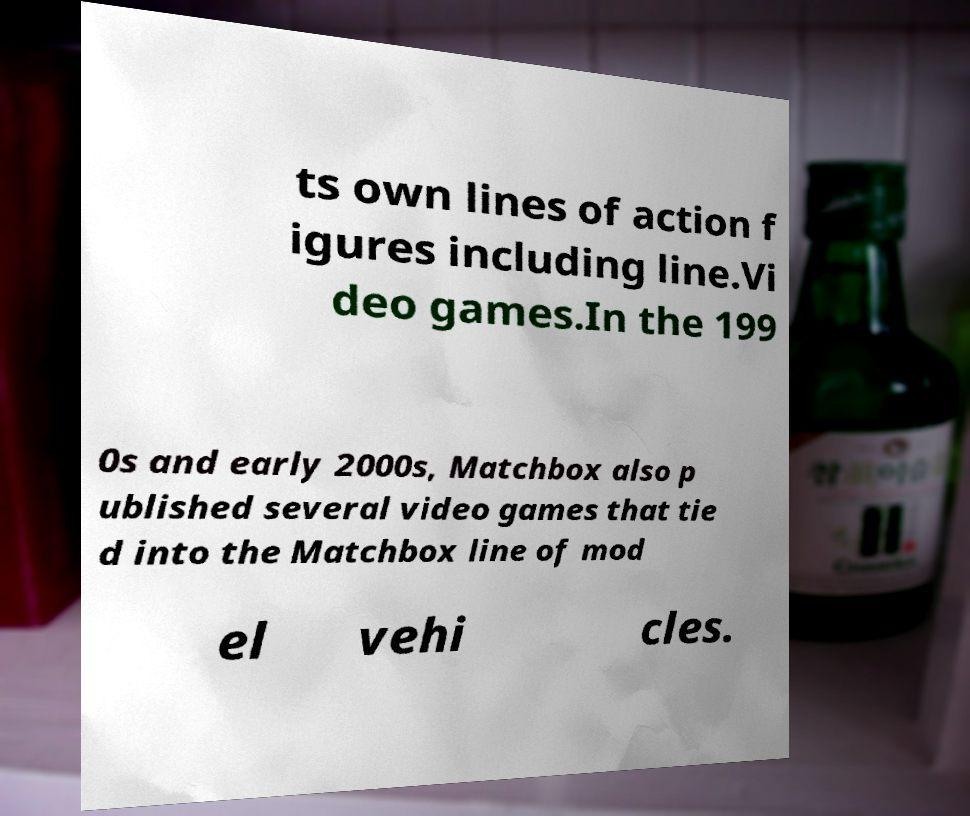What messages or text are displayed in this image? I need them in a readable, typed format. ts own lines of action f igures including line.Vi deo games.In the 199 0s and early 2000s, Matchbox also p ublished several video games that tie d into the Matchbox line of mod el vehi cles. 